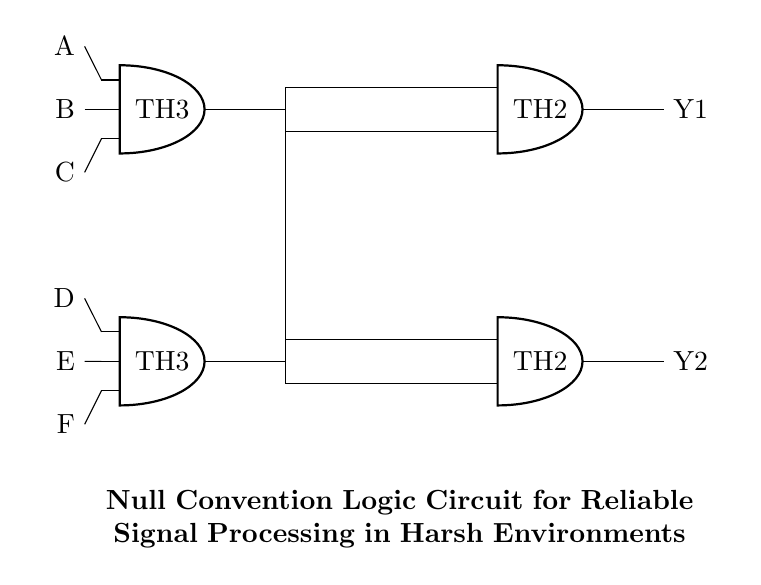What gates are used in this circuit? The circuit consists of Threshold gates, specifically TH3 and TH2, as indicated by their labels within the diagram. Each gate processes input signals according to their specified logic.
Answer: TH3, TH2 How many inputs does the TH3 gate have? The TH3 gate is specified as having three inputs, as indicated by the label "number inputs=3" in the circuit diagram. The connections made to the TH3 also demonstrate the three input lines feeding into it.
Answer: Three What are the output signals of this circuit? The circuit produces two output signals, which are denoted as Y1 and Y2, emerging from TH2 and TH3 respectively. These are clearly labeled on the right side of the circuit diagram.
Answer: Y1, Y2 Which gates are interconnected to the TH4 gate? The TH4 gate is interconnected with the two previous gates: TH2 and TH1. This is shown through the lines drawn connecting the outputs of TH1 and TH2 to the inputs of TH4 in the diagram.
Answer: TH2, TH1 What is the purpose of this circuit? The circuit is designed for reliable signal processing in harsh environments, as stated in the title section of the diagram. The Null Convention Logic approach is beneficial for maintaining signal integrity under such conditions.
Answer: Reliable signal processing How many total input signals are there in this circuit? There are six total input signals labeled A, B, C, D, E, and F as shown on the left side of the diagram. Each is tied to different sets of gates, confirming the total count.
Answer: Six What logic does the Interconnections in this circuit represent? The interconnections represent a combination of logical AND operations from the Threshold gates, which indicates that an output is active only when certain conditions (input signals) are met. This type of operation is essential for achieving reliable output in various logic levels.
Answer: Logic AND 